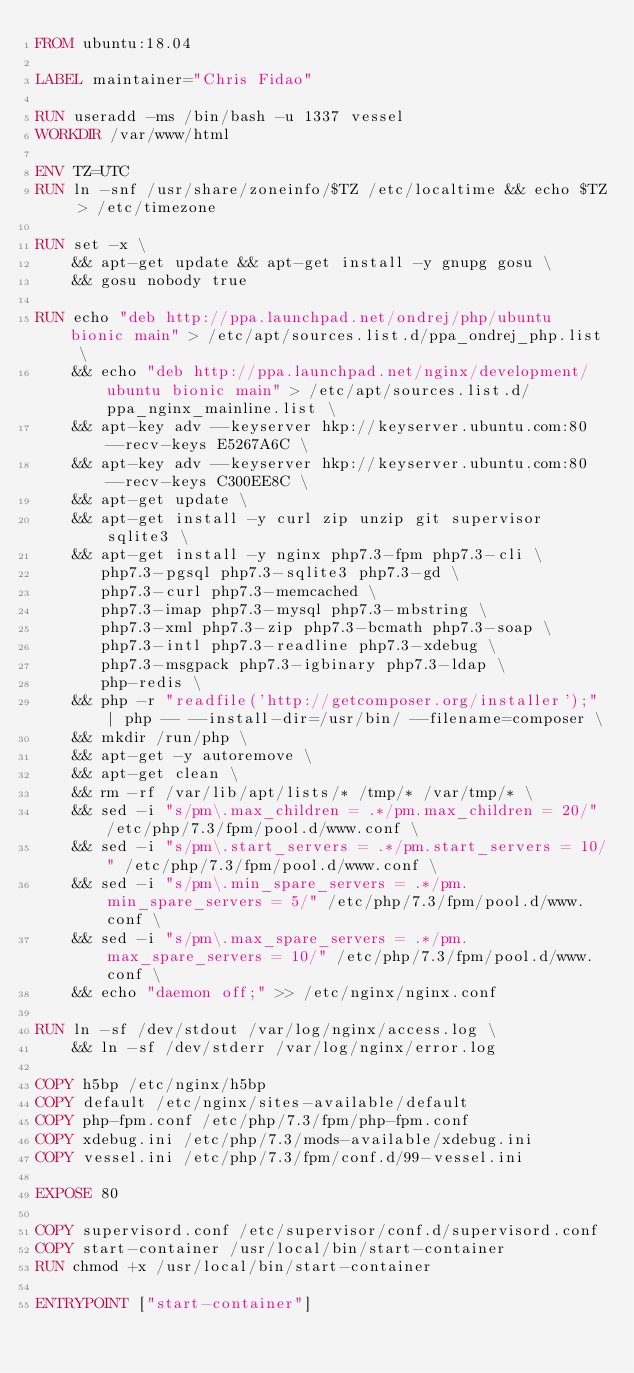<code> <loc_0><loc_0><loc_500><loc_500><_Dockerfile_>FROM ubuntu:18.04

LABEL maintainer="Chris Fidao"

RUN useradd -ms /bin/bash -u 1337 vessel
WORKDIR /var/www/html

ENV TZ=UTC
RUN ln -snf /usr/share/zoneinfo/$TZ /etc/localtime && echo $TZ > /etc/timezone

RUN set -x \
    && apt-get update && apt-get install -y gnupg gosu \
    && gosu nobody true

RUN echo "deb http://ppa.launchpad.net/ondrej/php/ubuntu bionic main" > /etc/apt/sources.list.d/ppa_ondrej_php.list \
    && echo "deb http://ppa.launchpad.net/nginx/development/ubuntu bionic main" > /etc/apt/sources.list.d/ppa_nginx_mainline.list \
    && apt-key adv --keyserver hkp://keyserver.ubuntu.com:80 --recv-keys E5267A6C \
    && apt-key adv --keyserver hkp://keyserver.ubuntu.com:80 --recv-keys C300EE8C \
    && apt-get update \
    && apt-get install -y curl zip unzip git supervisor sqlite3 \
    && apt-get install -y nginx php7.3-fpm php7.3-cli \
       php7.3-pgsql php7.3-sqlite3 php7.3-gd \
       php7.3-curl php7.3-memcached \
       php7.3-imap php7.3-mysql php7.3-mbstring \
       php7.3-xml php7.3-zip php7.3-bcmath php7.3-soap \
       php7.3-intl php7.3-readline php7.3-xdebug \
       php7.3-msgpack php7.3-igbinary php7.3-ldap \
       php-redis \
    && php -r "readfile('http://getcomposer.org/installer');" | php -- --install-dir=/usr/bin/ --filename=composer \
    && mkdir /run/php \
    && apt-get -y autoremove \
    && apt-get clean \
    && rm -rf /var/lib/apt/lists/* /tmp/* /var/tmp/* \
    && sed -i "s/pm\.max_children = .*/pm.max_children = 20/" /etc/php/7.3/fpm/pool.d/www.conf \
    && sed -i "s/pm\.start_servers = .*/pm.start_servers = 10/" /etc/php/7.3/fpm/pool.d/www.conf \
    && sed -i "s/pm\.min_spare_servers = .*/pm.min_spare_servers = 5/" /etc/php/7.3/fpm/pool.d/www.conf \
    && sed -i "s/pm\.max_spare_servers = .*/pm.max_spare_servers = 10/" /etc/php/7.3/fpm/pool.d/www.conf \
    && echo "daemon off;" >> /etc/nginx/nginx.conf

RUN ln -sf /dev/stdout /var/log/nginx/access.log \
    && ln -sf /dev/stderr /var/log/nginx/error.log

COPY h5bp /etc/nginx/h5bp
COPY default /etc/nginx/sites-available/default
COPY php-fpm.conf /etc/php/7.3/fpm/php-fpm.conf
COPY xdebug.ini /etc/php/7.3/mods-available/xdebug.ini
COPY vessel.ini /etc/php/7.3/fpm/conf.d/99-vessel.ini

EXPOSE 80

COPY supervisord.conf /etc/supervisor/conf.d/supervisord.conf
COPY start-container /usr/local/bin/start-container
RUN chmod +x /usr/local/bin/start-container

ENTRYPOINT ["start-container"]
</code> 